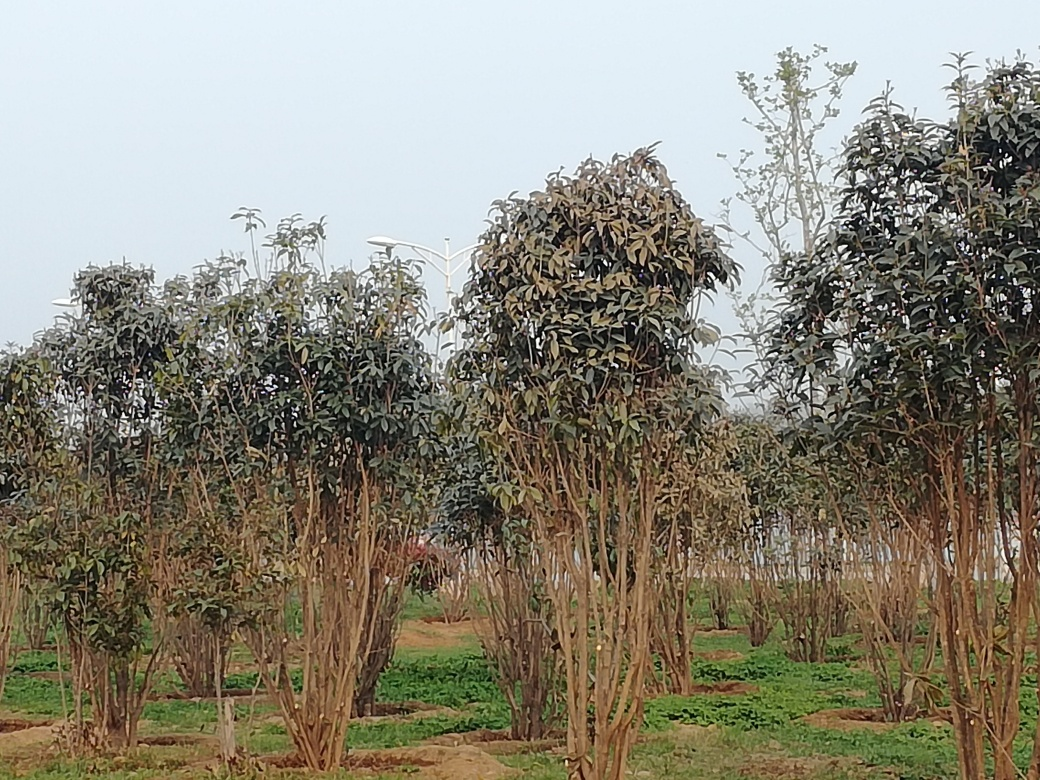What type of trees are these, and are they healthy? These trees appear to be young deciduous trees, possibly in an orchard or plantation. Some exhibit signs of stress, as indicated by the brownish leaves, which might suggest a change in season, environmental stress, or disease. How could the health of these trees be assessed more accurately? A closer examination of the leaves, branches, and trunk could provide more insights. Additionally, soil tests and overall inspection of the plantation's environment would offer valuable information regarding their health and the care they might need. 